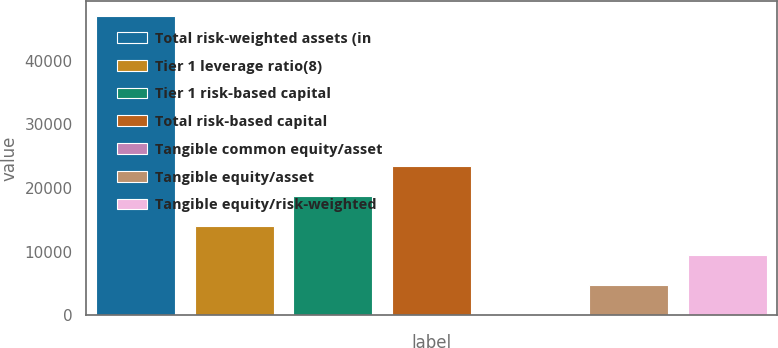Convert chart. <chart><loc_0><loc_0><loc_500><loc_500><bar_chart><fcel>Total risk-weighted assets (in<fcel>Tier 1 leverage ratio(8)<fcel>Tier 1 risk-based capital<fcel>Total risk-based capital<fcel>Tangible common equity/asset<fcel>Tangible equity/asset<fcel>Tangible equity/risk-weighted<nl><fcel>46994<fcel>14101<fcel>18800<fcel>23499<fcel>4.04<fcel>4703.04<fcel>9402.04<nl></chart> 